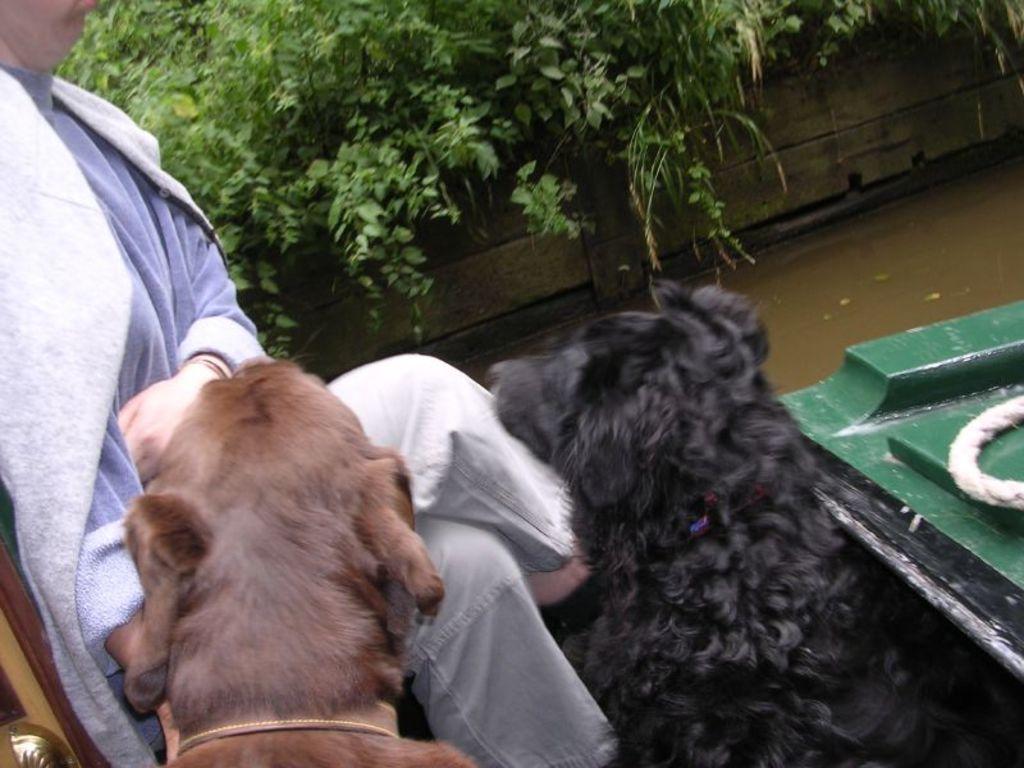Can you describe this image briefly? In the picture I can see dogs and a person is sitting on a boat. In the background I can see the water, plants, a wall and white color rope on a boat. 